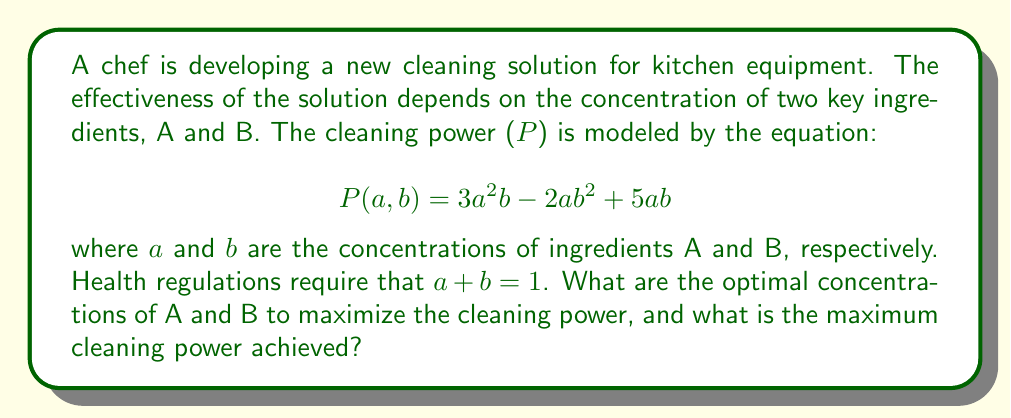Show me your answer to this math problem. To solve this problem, we can use the method of Lagrange multipliers:

1) First, we define the Lagrangian function:
   $$L(a,b,\lambda) = 3a^2b - 2ab^2 + 5ab + \lambda(a + b - 1)$$

2) We then set the partial derivatives equal to zero:

   $$\frac{\partial L}{\partial a} = 6ab + 3a^2 - 2b^2 + 5b + \lambda = 0$$
   $$\frac{\partial L}{\partial b} = 3a^2 - 4ab + 5a + \lambda = 0$$
   $$\frac{\partial L}{\partial \lambda} = a + b - 1 = 0$$

3) From the last equation, we can substitute $b = 1 - a$ into the first two equations:

   $$6a(1-a) + 3a^2 - 2(1-a)^2 + 5(1-a) + \lambda = 0$$
   $$3a^2 - 4a(1-a) + 5a + \lambda = 0$$

4) Simplifying:

   $$-3a^2 + 4a + 3 + \lambda = 0$$
   $$3a^2 - 4a + 5a + \lambda = 0$$

5) Subtracting the second equation from the first:

   $$-6a^2 + 8a - 2 = 0$$

6) Solving this quadratic equation:

   $$a = \frac{4 \pm \sqrt{16 + 12}}{6} = \frac{4 \pm \sqrt{28}}{6}$$

   The positive solution is $a = \frac{4 + \sqrt{28}}{6} \approx 0.8819$

7) Therefore, $b = 1 - a \approx 0.1181$

8) The maximum cleaning power is:

   $$P(0.8819, 0.1181) = 3(0.8819)^2(0.1181) - 2(0.8819)(0.1181)^2 + 5(0.8819)(0.1181) \approx 0.4934$$
Answer: The optimal concentrations are approximately 88.19% for ingredient A and 11.81% for ingredient B. The maximum cleaning power achieved is approximately 0.4934. 